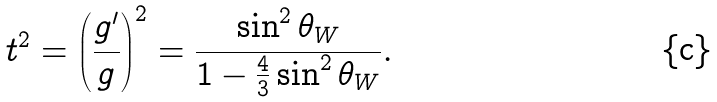<formula> <loc_0><loc_0><loc_500><loc_500>t ^ { 2 } = \left ( \frac { g ^ { \prime } } { g } \right ) ^ { 2 } = \frac { \sin ^ { 2 } \theta _ { W } } { 1 - \frac { 4 } { 3 } \sin ^ { 2 } \theta _ { W } } .</formula> 